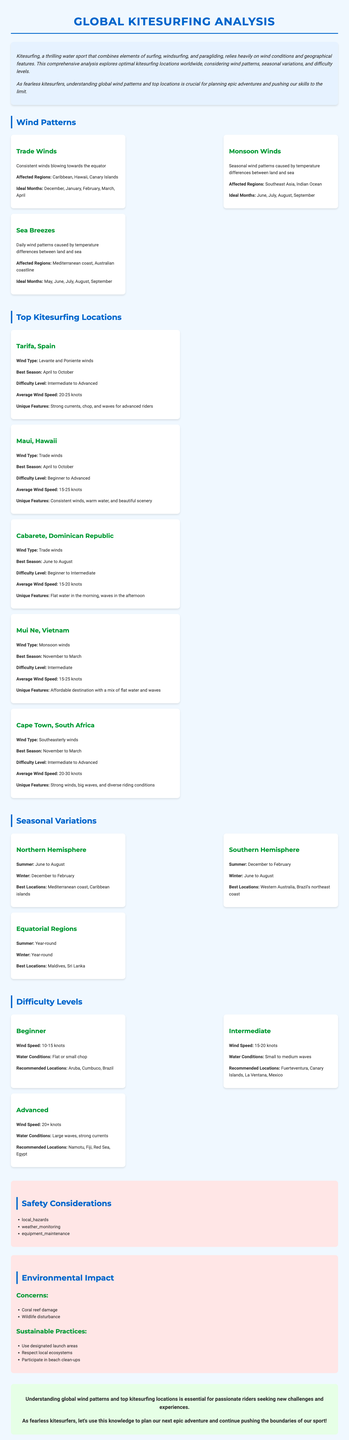What are the ideal months for trade winds? The ideal months for trade winds, as noted in the wind patterns section, include December, January, February, March, and April.
Answer: December, January, February, March, April Which kitesurfing location has an average wind speed of 20-30 knots? Cape Town, South Africa is specified to have an average wind speed of 20-30 knots as highlighted in the top kitesurfing locations section.
Answer: Cape Town, South Africa What is the difficulty level for Mui Ne, Vietnam? The difficulty level for Mui Ne, Vietnam is categorized as Intermediate according to the description in the top kitesurfing locations section.
Answer: Intermediate How many recommended locations are there for advanced kitesurfers? The advanced difficulty level lists two recommended locations, specifically Namotu, Fiji and the Red Sea, Egypt.
Answer: Two What weather monitoring considerations are mentioned in the report? The report notes that kitesurfers should monitor wind forecasts, tide charts, and storm warnings for safety.
Answer: Wind forecasts, tide charts, storm warnings What is the best season to kitesurf in Cabarete, Dominican Republic? The report specifies that the best season for kitesurfing in Cabarete, Dominican Republic is June to August.
Answer: June to August Which hemisphere has its summer from December to February? The southern hemisphere is outlined to have its summer from December to February in the seasonal variations section.
Answer: Southern hemisphere What type of wind pattern affects the Australian coastline? Sea breezes are identified as the wind pattern affecting the Australian coastline based on the wind patterns section.
Answer: Sea breezes 